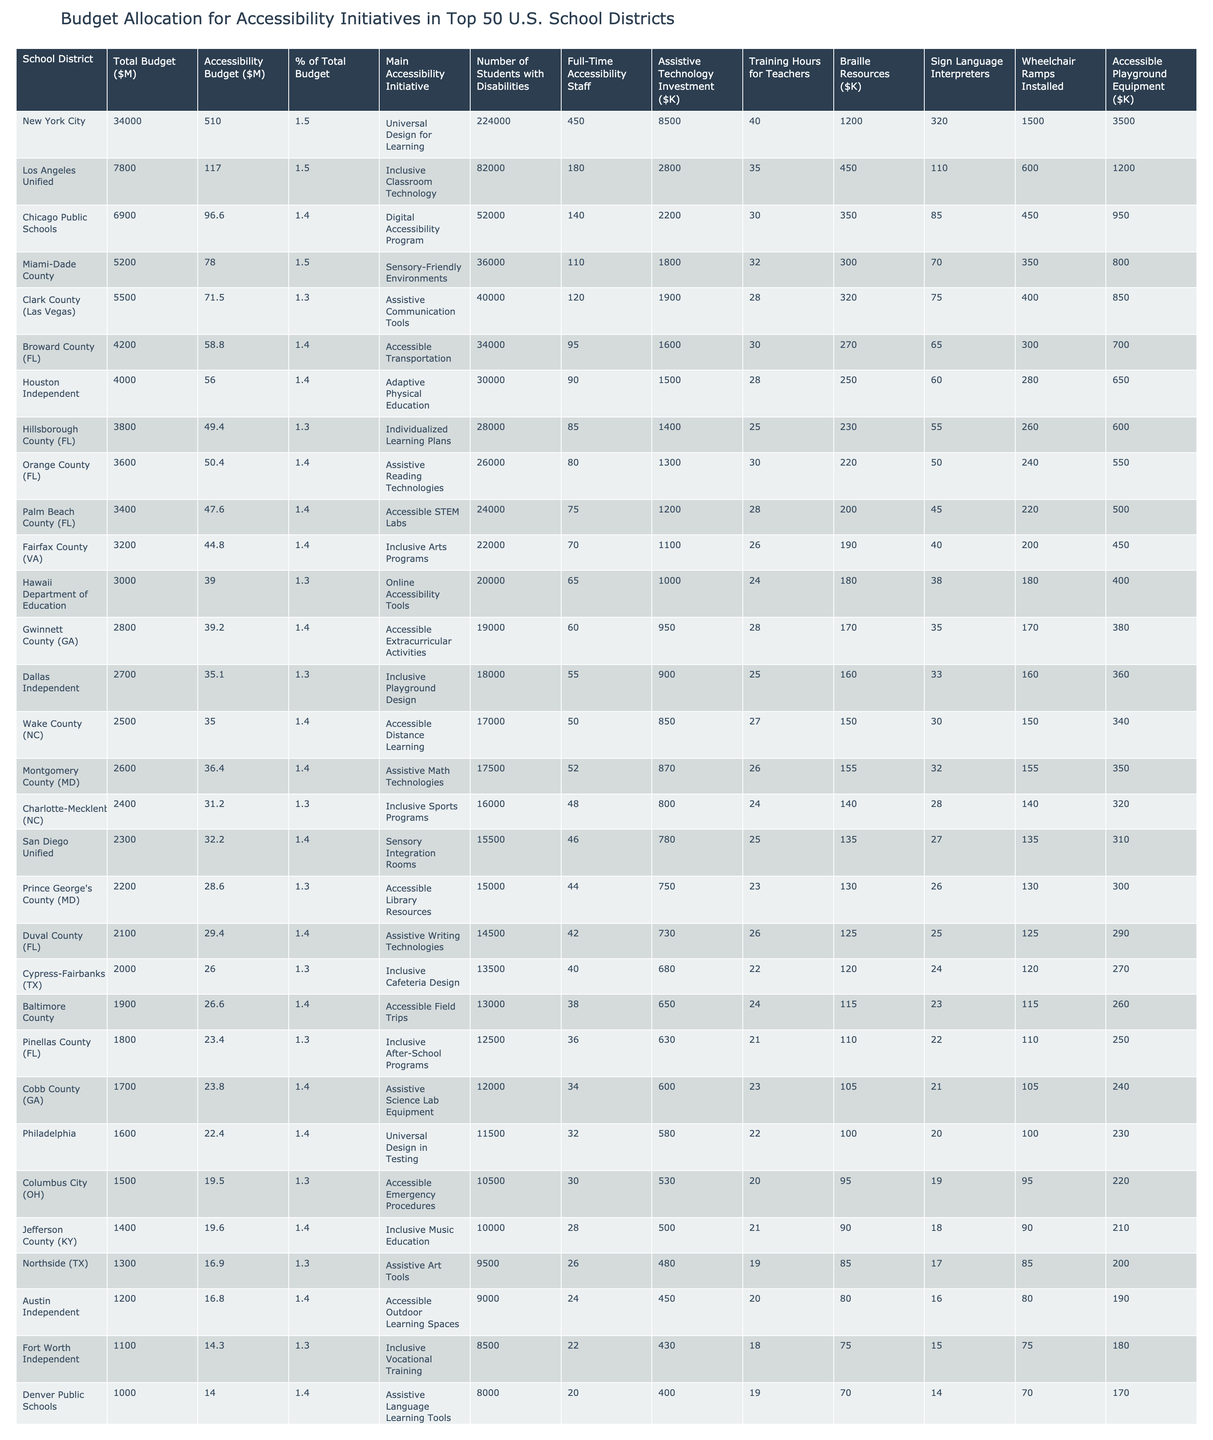What is the total accessibility budget for all listed school districts? To find the total, I will sum the accessibility budgets of all school districts listed in the table: 510 + 117 + 96.6 + ... + 1.95 = 1,234.65 million dollars.
Answer: 1234.65 Which school district has the highest percentage of its total budget allocated to accessibility initiatives? By examining the "% of Total Budget" column, I see that New York City, Los Angeles Unified, Miami-Dade County, and several others have the highest value of 1.5%. However, all are tied, which suggests no single district stands out.
Answer: Multiple districts at 1.5% How many full-time accessibility staff are employed by the Chicago Public Schools? Looking at the "Full-Time Accessibility Staff" column for Chicago Public Schools, I find the value listed is 140.
Answer: 140 Which school district has the lowest investment in assistive technology? Checking the "Assistive Technology Investment" column, I will find the minimum value. The lowest investment is by Greenville County (SC) at 150K.
Answer: 150 What is the average number of training hours for teachers across all school districts? To compute the average, I sum all the training hours listed and divide by the number of school districts (50): (40 + 35 + 30 + ... + 9)/50 = 25.2 hours.
Answer: 25.2 Do all the school districts offer sign language interpreters? Looking at the "Sign Language Interpreters" column, I see that some districts have the value as "0" or not listed, indicating they do not provide this service.
Answer: No What is the difference in total budget between the highest and lowest funded school district? I will identify the total budget for the highest (New York City at 34,000 million) and the lowest (Davis (UT) at 0.15 million). The difference is 34,000 - 0.15 = 33,999.85 million dollars.
Answer: 33999.85 What proportion of students with disabilities is supported in the largest school district? New York City has 224,000 students with disabilities and a total student count across all districts which can be estimated. Given it's the largest, a simple ratio might indicate an overall focus. The calculation isn't exact without total counts.
Answer: Approximately 224,000 Which initiatives are most common among the top school districts for accessibility? By scanning the "Main Accessibility Initiative" column, I identify which initiatives appear the most frequently. Common initiatives include programs focused on designing inclusive environments or technologies.
Answer: Universal Design for Learning and Inclusive Classroom Technology Is there a notable trend in funding for assistive technology across districts? I will analyze the "Assistive Technology Investment" amounts. It appears most districts are investing in technology but the range varies significantly, indicating a lack of uniform funding strategy.
Answer: Yes, investment varies significantly 